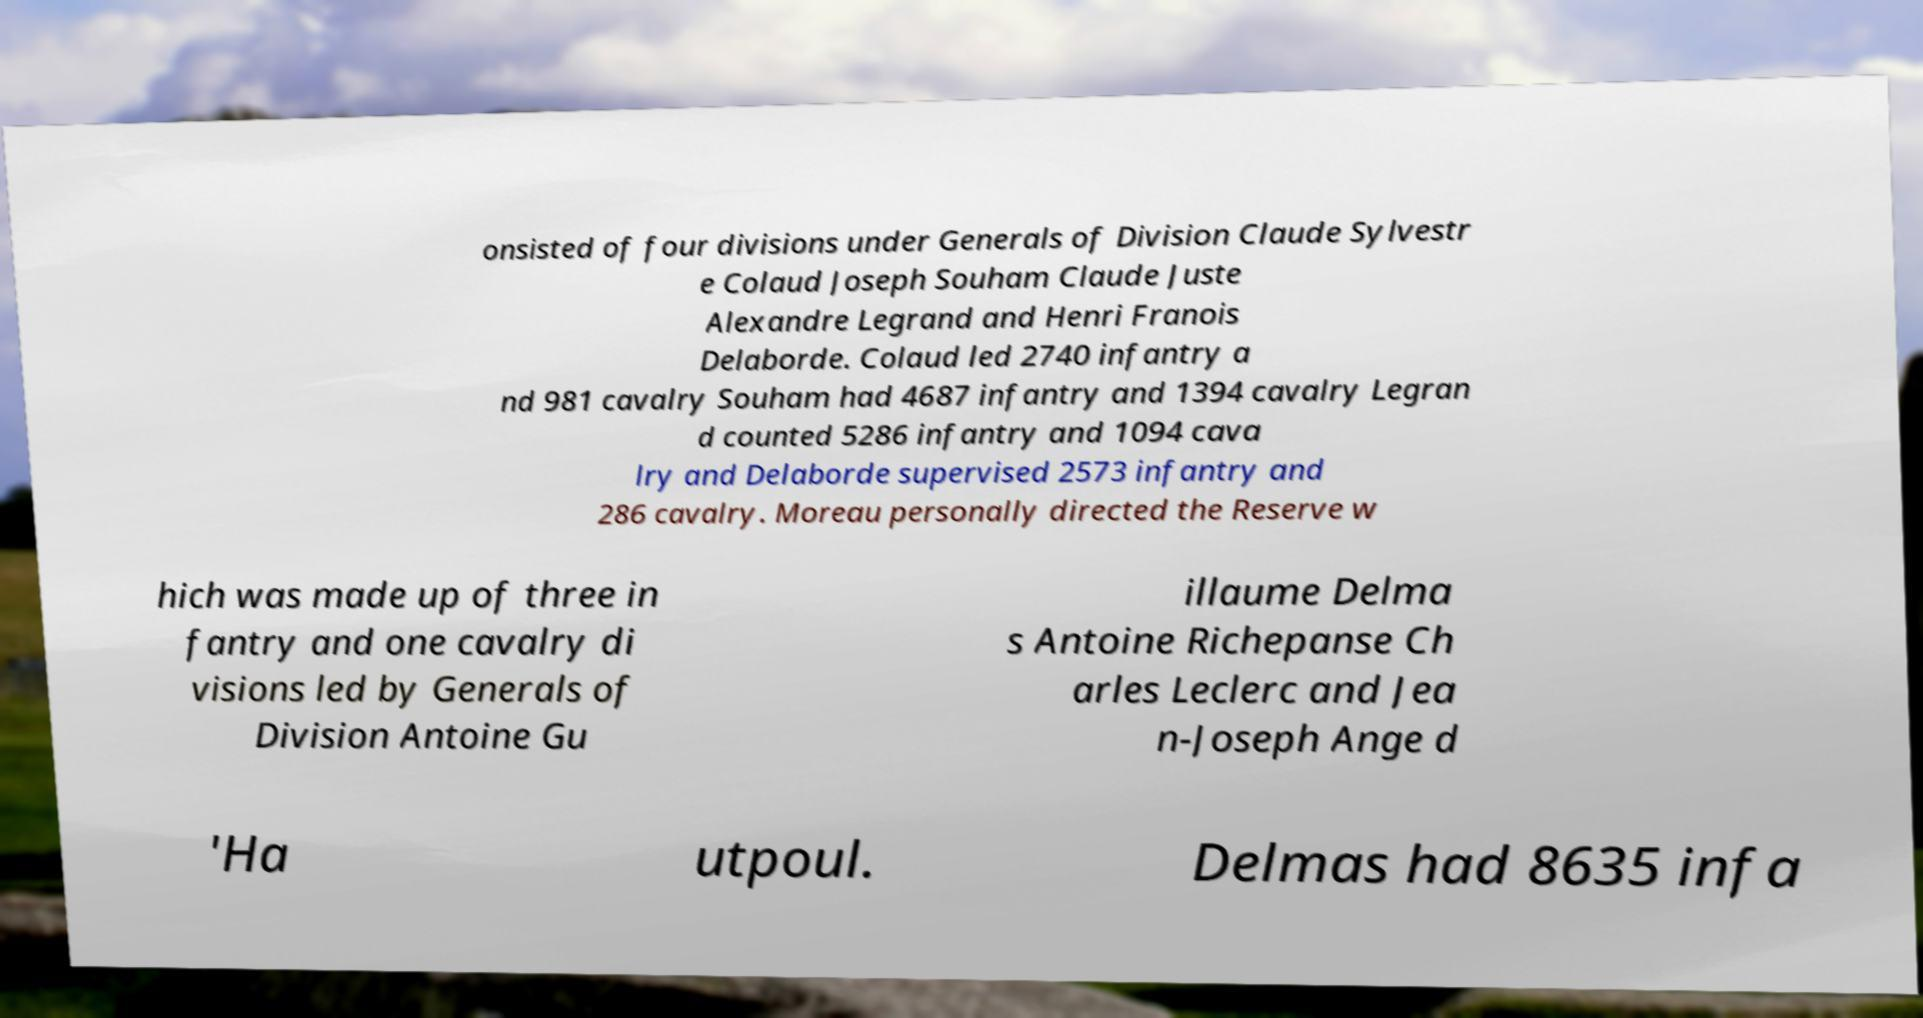Can you read and provide the text displayed in the image?This photo seems to have some interesting text. Can you extract and type it out for me? onsisted of four divisions under Generals of Division Claude Sylvestr e Colaud Joseph Souham Claude Juste Alexandre Legrand and Henri Franois Delaborde. Colaud led 2740 infantry a nd 981 cavalry Souham had 4687 infantry and 1394 cavalry Legran d counted 5286 infantry and 1094 cava lry and Delaborde supervised 2573 infantry and 286 cavalry. Moreau personally directed the Reserve w hich was made up of three in fantry and one cavalry di visions led by Generals of Division Antoine Gu illaume Delma s Antoine Richepanse Ch arles Leclerc and Jea n-Joseph Ange d 'Ha utpoul. Delmas had 8635 infa 